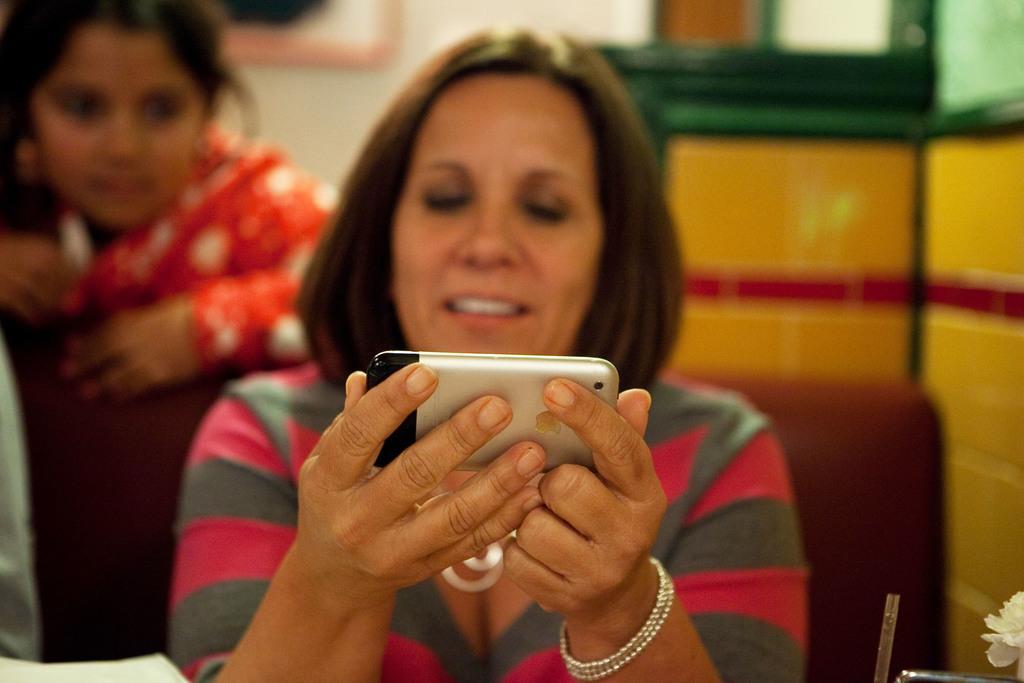Could you give a brief overview of what you see in this image? A woman in t-shirt, smiling and watching to the mobile. And she is sitting on a chair. In the background another woman, watching to the mobile. Beside her, there is a wall. 